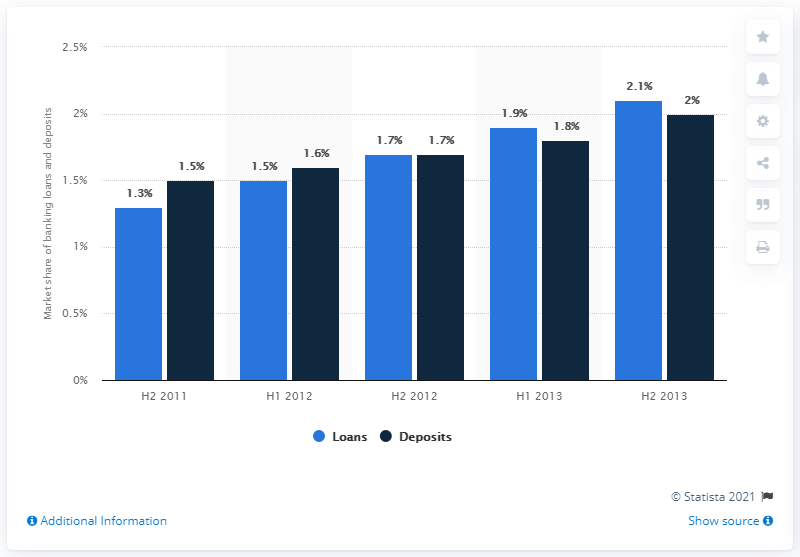Indicate a few pertinent items in this graphic. The market share of loans in the second half of 2013 was 2.1%. 